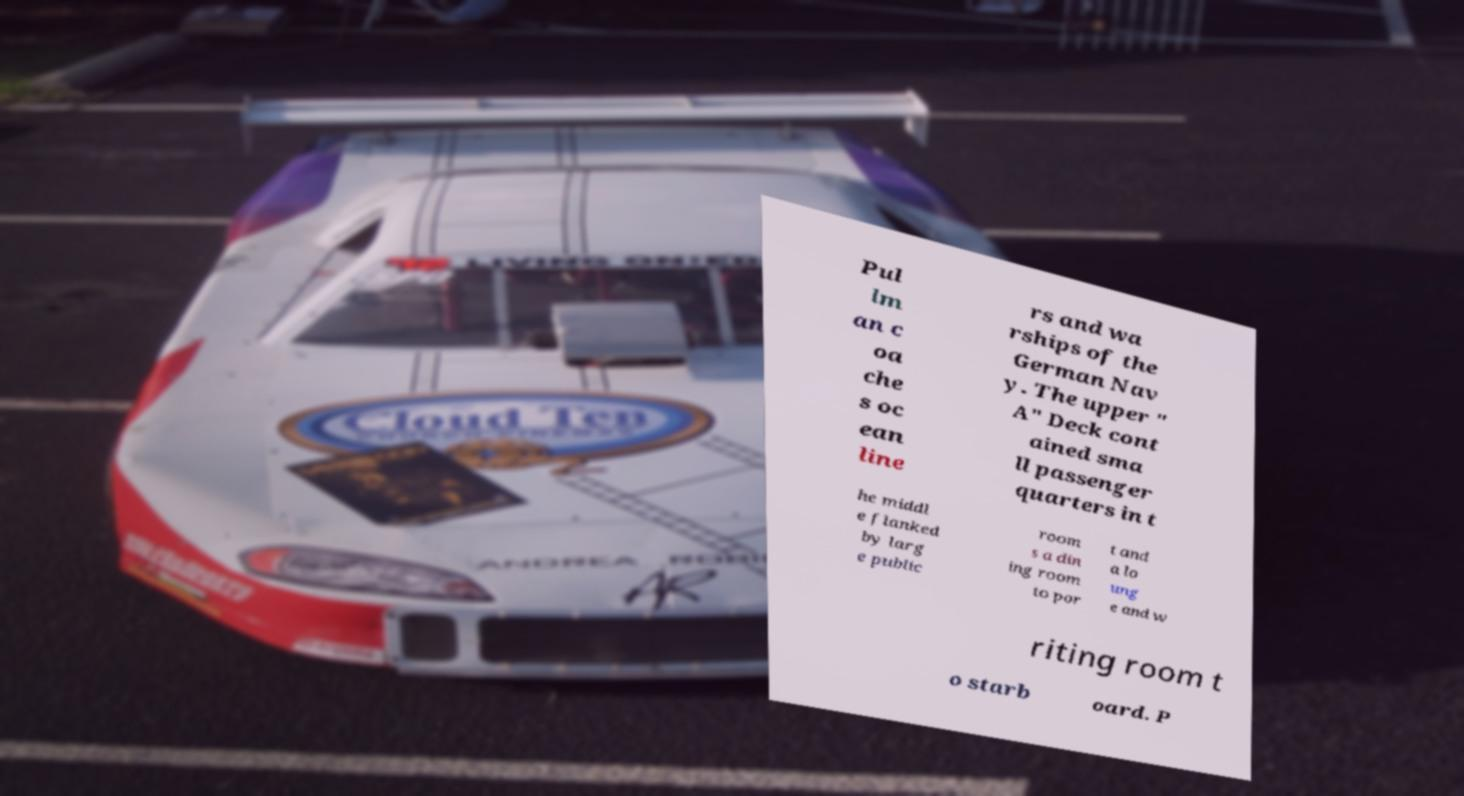Can you read and provide the text displayed in the image?This photo seems to have some interesting text. Can you extract and type it out for me? Pul lm an c oa che s oc ean line rs and wa rships of the German Nav y. The upper " A" Deck cont ained sma ll passenger quarters in t he middl e flanked by larg e public room s a din ing room to por t and a lo ung e and w riting room t o starb oard. P 